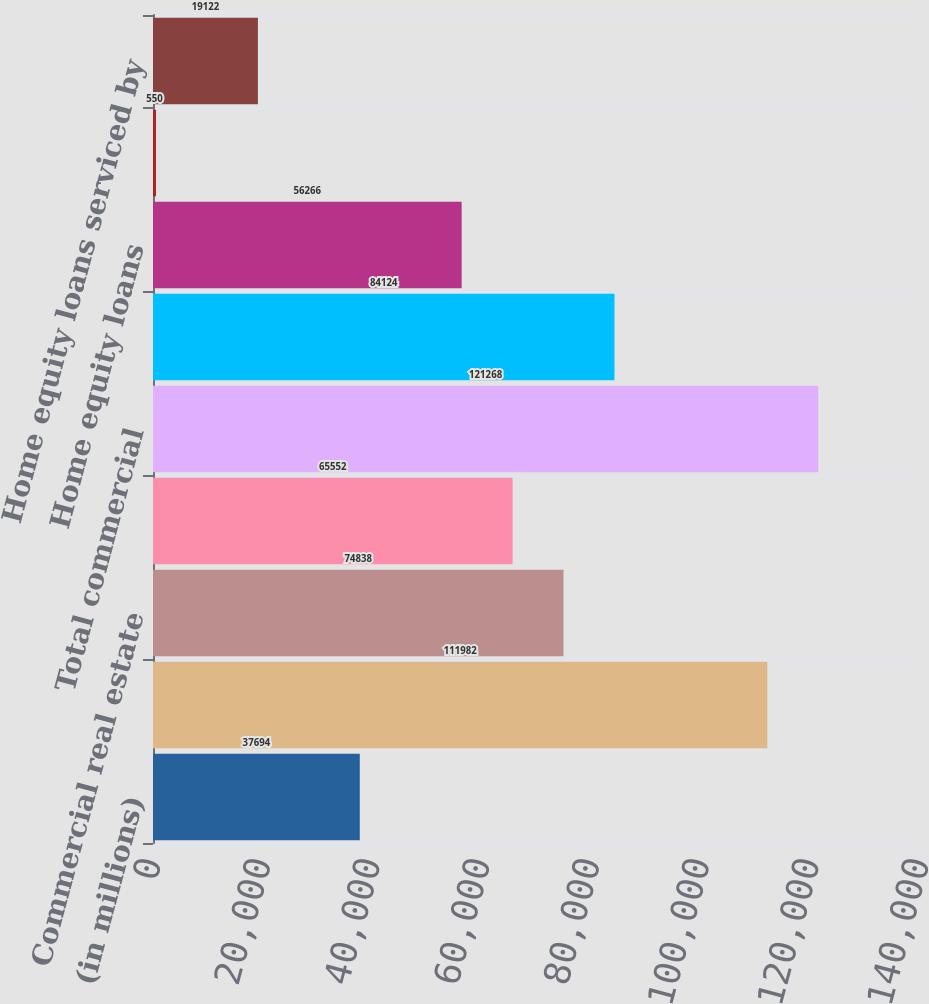Convert chart. <chart><loc_0><loc_0><loc_500><loc_500><bar_chart><fcel>(in millions)<fcel>Commercial<fcel>Commercial real estate<fcel>Leases<fcel>Total commercial<fcel>Residential mortgages<fcel>Home equity loans<fcel>Home equity lines of credit<fcel>Home equity loans serviced by<nl><fcel>37694<fcel>111982<fcel>74838<fcel>65552<fcel>121268<fcel>84124<fcel>56266<fcel>550<fcel>19122<nl></chart> 